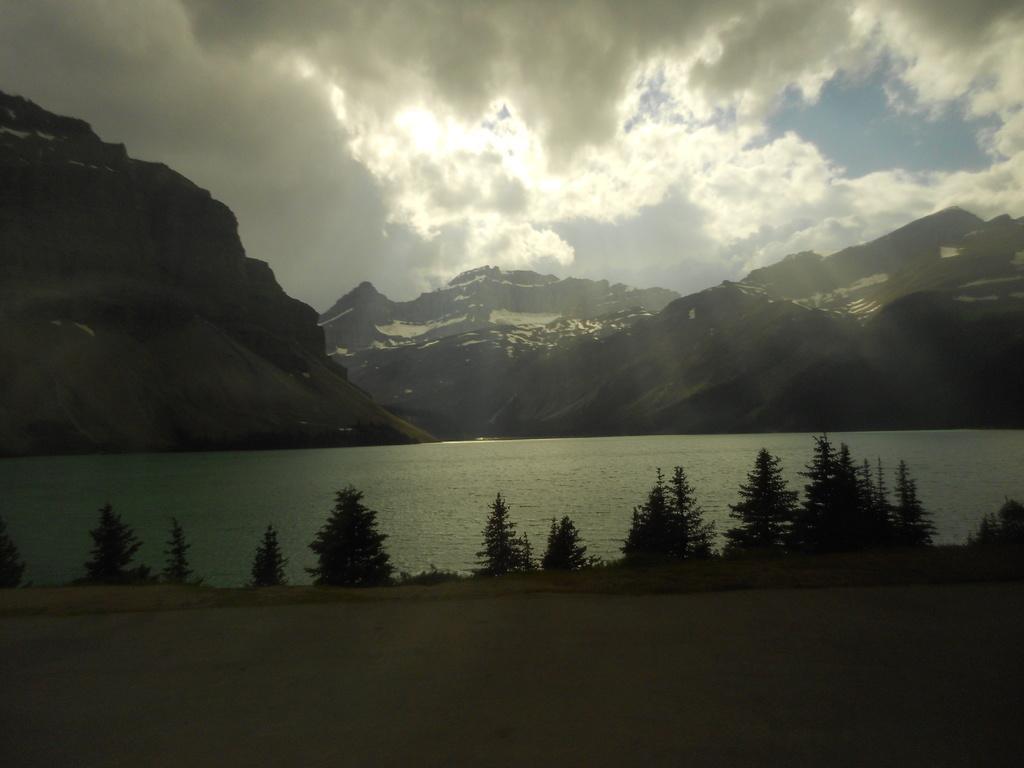Please provide a concise description of this image. In this picture I can see hills,water and few trees and I can see a blue cloudy sky. 